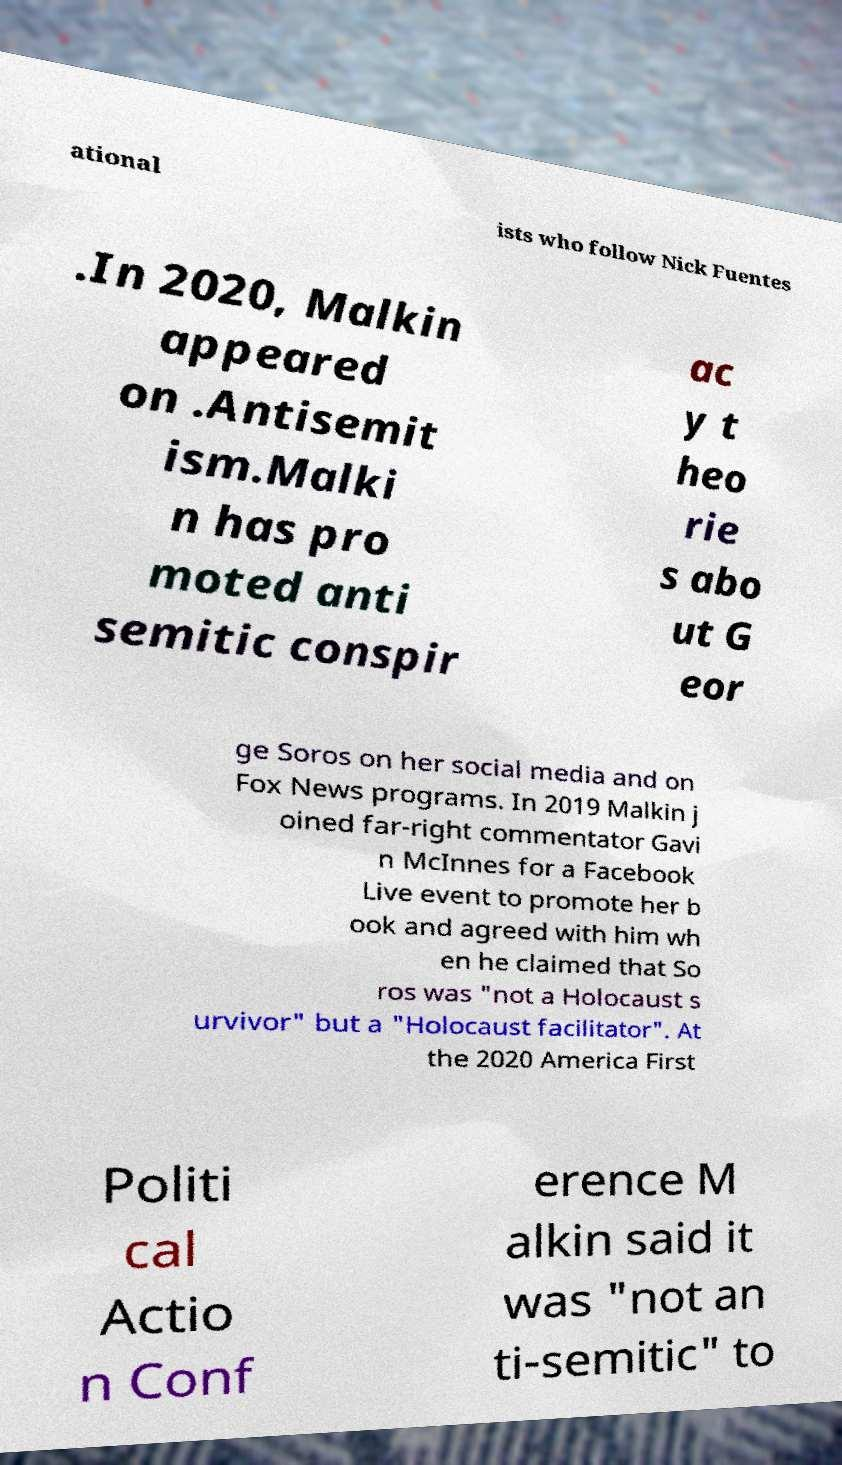Could you extract and type out the text from this image? ational ists who follow Nick Fuentes .In 2020, Malkin appeared on .Antisemit ism.Malki n has pro moted anti semitic conspir ac y t heo rie s abo ut G eor ge Soros on her social media and on Fox News programs. In 2019 Malkin j oined far-right commentator Gavi n McInnes for a Facebook Live event to promote her b ook and agreed with him wh en he claimed that So ros was "not a Holocaust s urvivor" but a "Holocaust facilitator". At the 2020 America First Politi cal Actio n Conf erence M alkin said it was "not an ti-semitic" to 